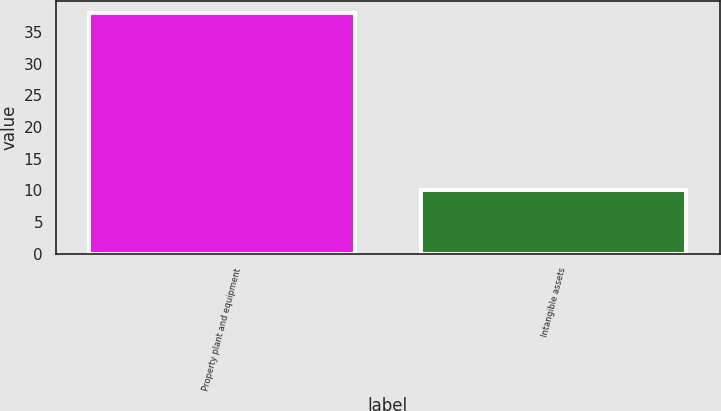Convert chart to OTSL. <chart><loc_0><loc_0><loc_500><loc_500><bar_chart><fcel>Property plant and equipment<fcel>Intangible assets<nl><fcel>38<fcel>10<nl></chart> 